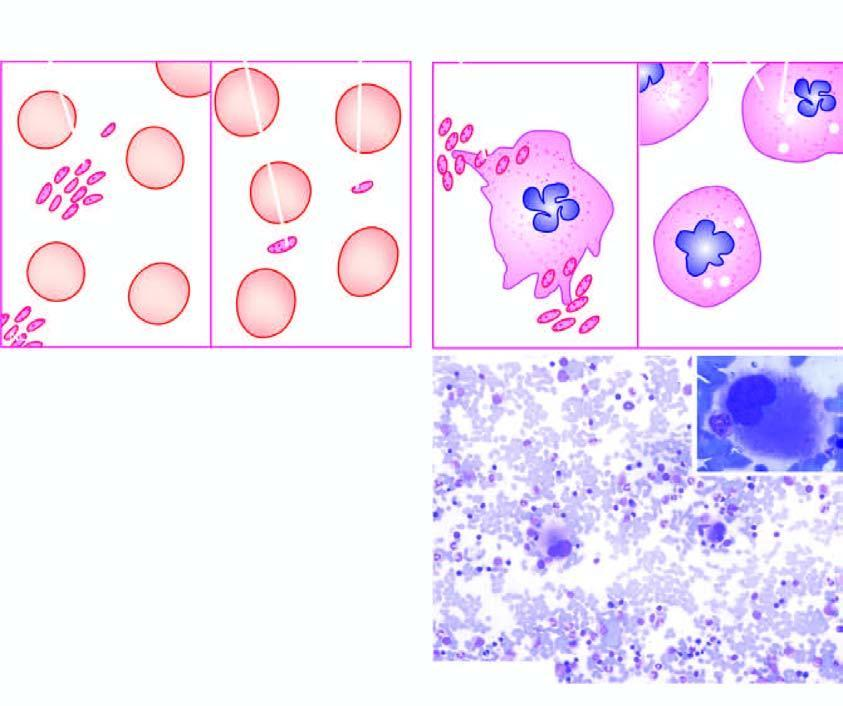how is laboratory findings of itp contrasted?
Answer the question using a single word or phrase. With those found normal individual 